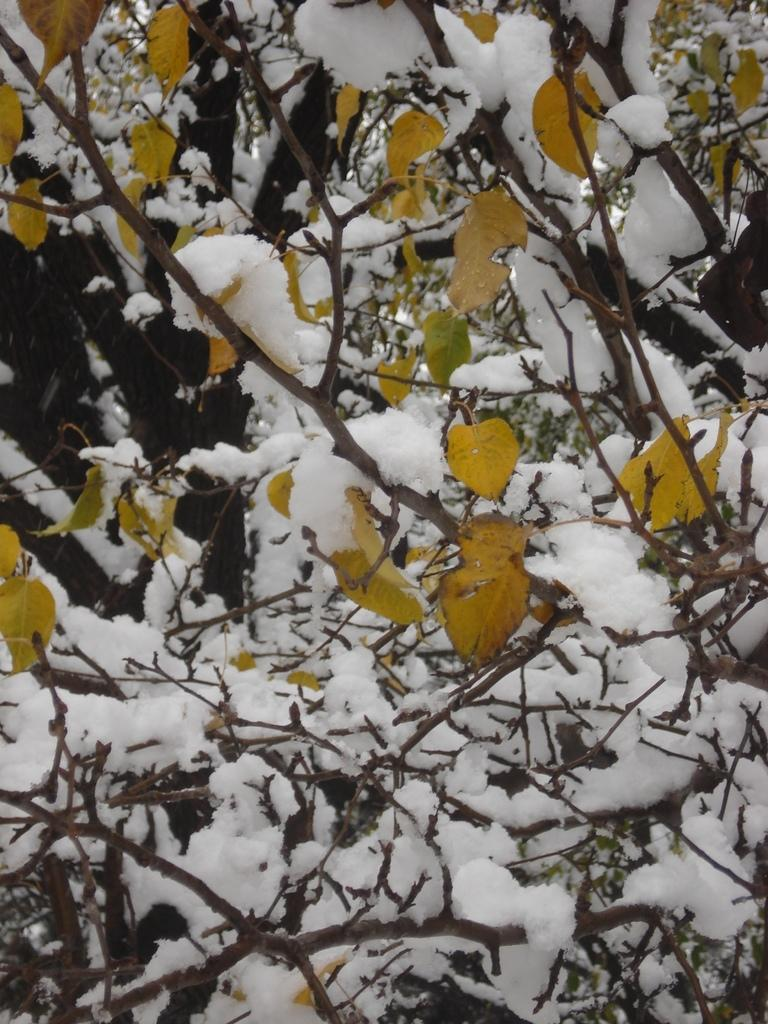What is the main subject of the image? The main subject of the image is the branches of a tree. What is covering the branches in the image? The branches are covered with ice. How many dust particles can be seen on the branches in the image? There is no mention of dust particles in the image; the branches are covered with ice. Are there any bears visible on the branches in the image? There is no mention of bears in the image; the branches are covered with ice. Can you see any roses growing on the branches in the image? There is no mention of roses in the image; the branches are covered with ice. 